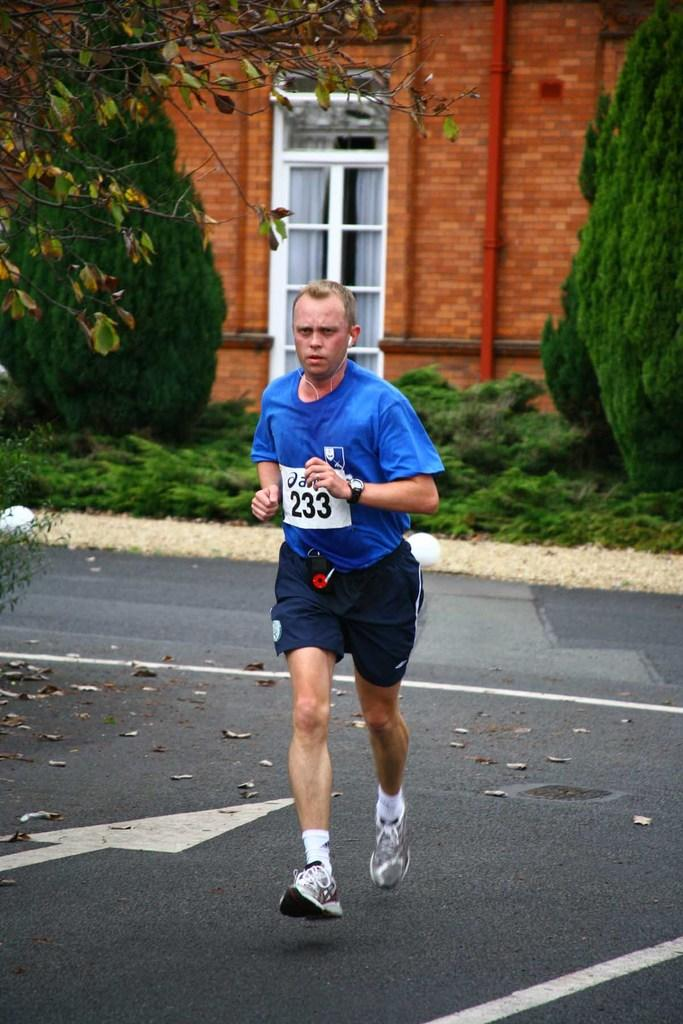<image>
Write a terse but informative summary of the picture. A man running in a roadway with the number 233 on his blue tshirt 